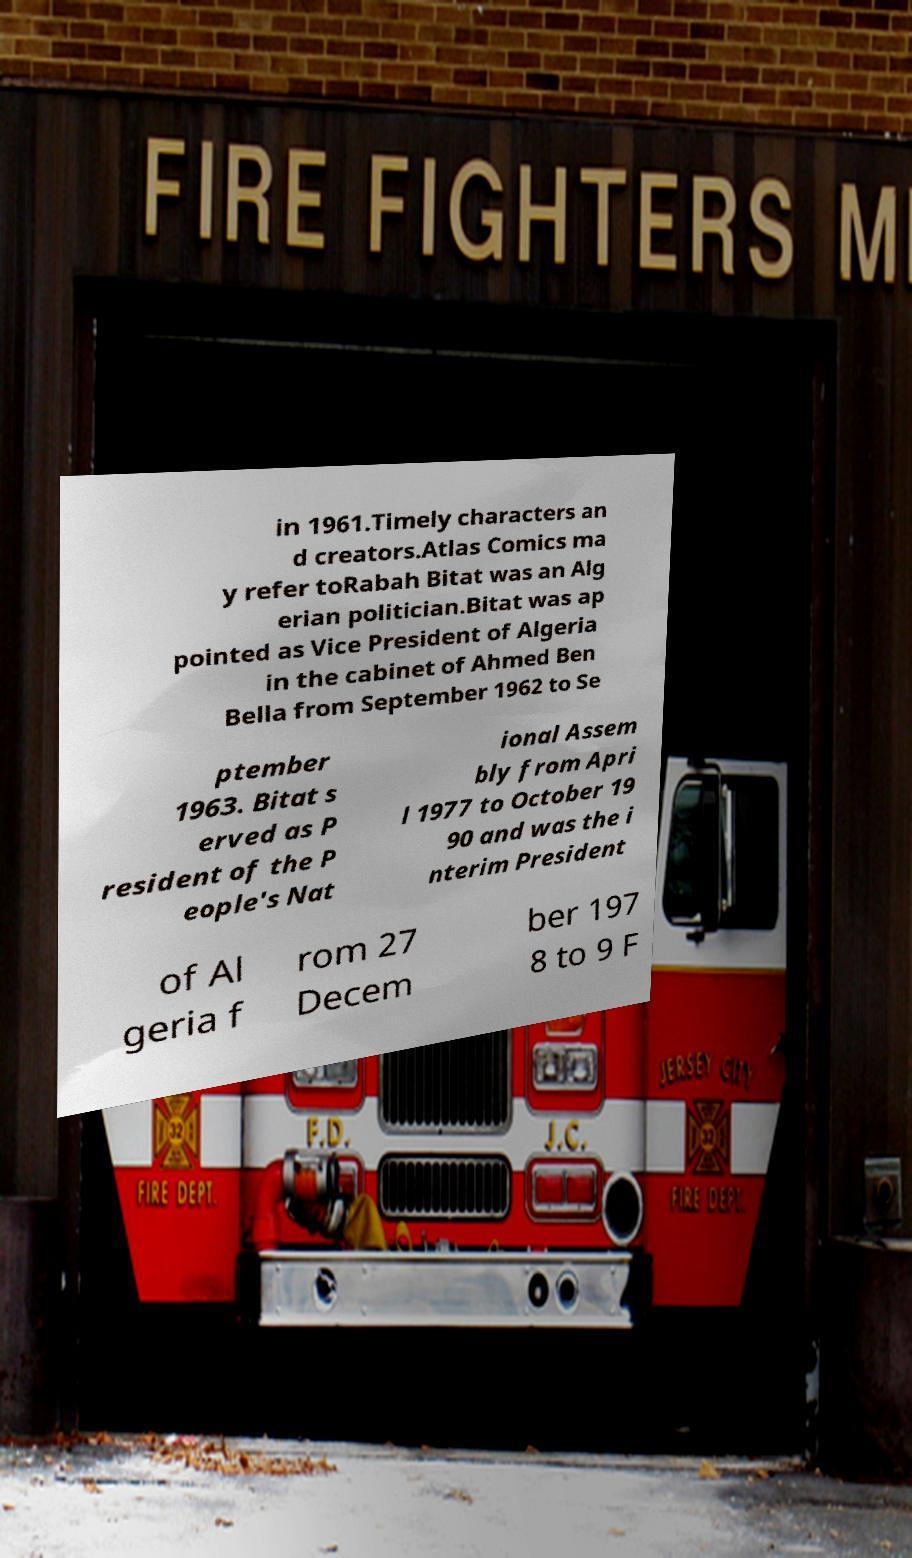There's text embedded in this image that I need extracted. Can you transcribe it verbatim? in 1961.Timely characters an d creators.Atlas Comics ma y refer toRabah Bitat was an Alg erian politician.Bitat was ap pointed as Vice President of Algeria in the cabinet of Ahmed Ben Bella from September 1962 to Se ptember 1963. Bitat s erved as P resident of the P eople's Nat ional Assem bly from Apri l 1977 to October 19 90 and was the i nterim President of Al geria f rom 27 Decem ber 197 8 to 9 F 